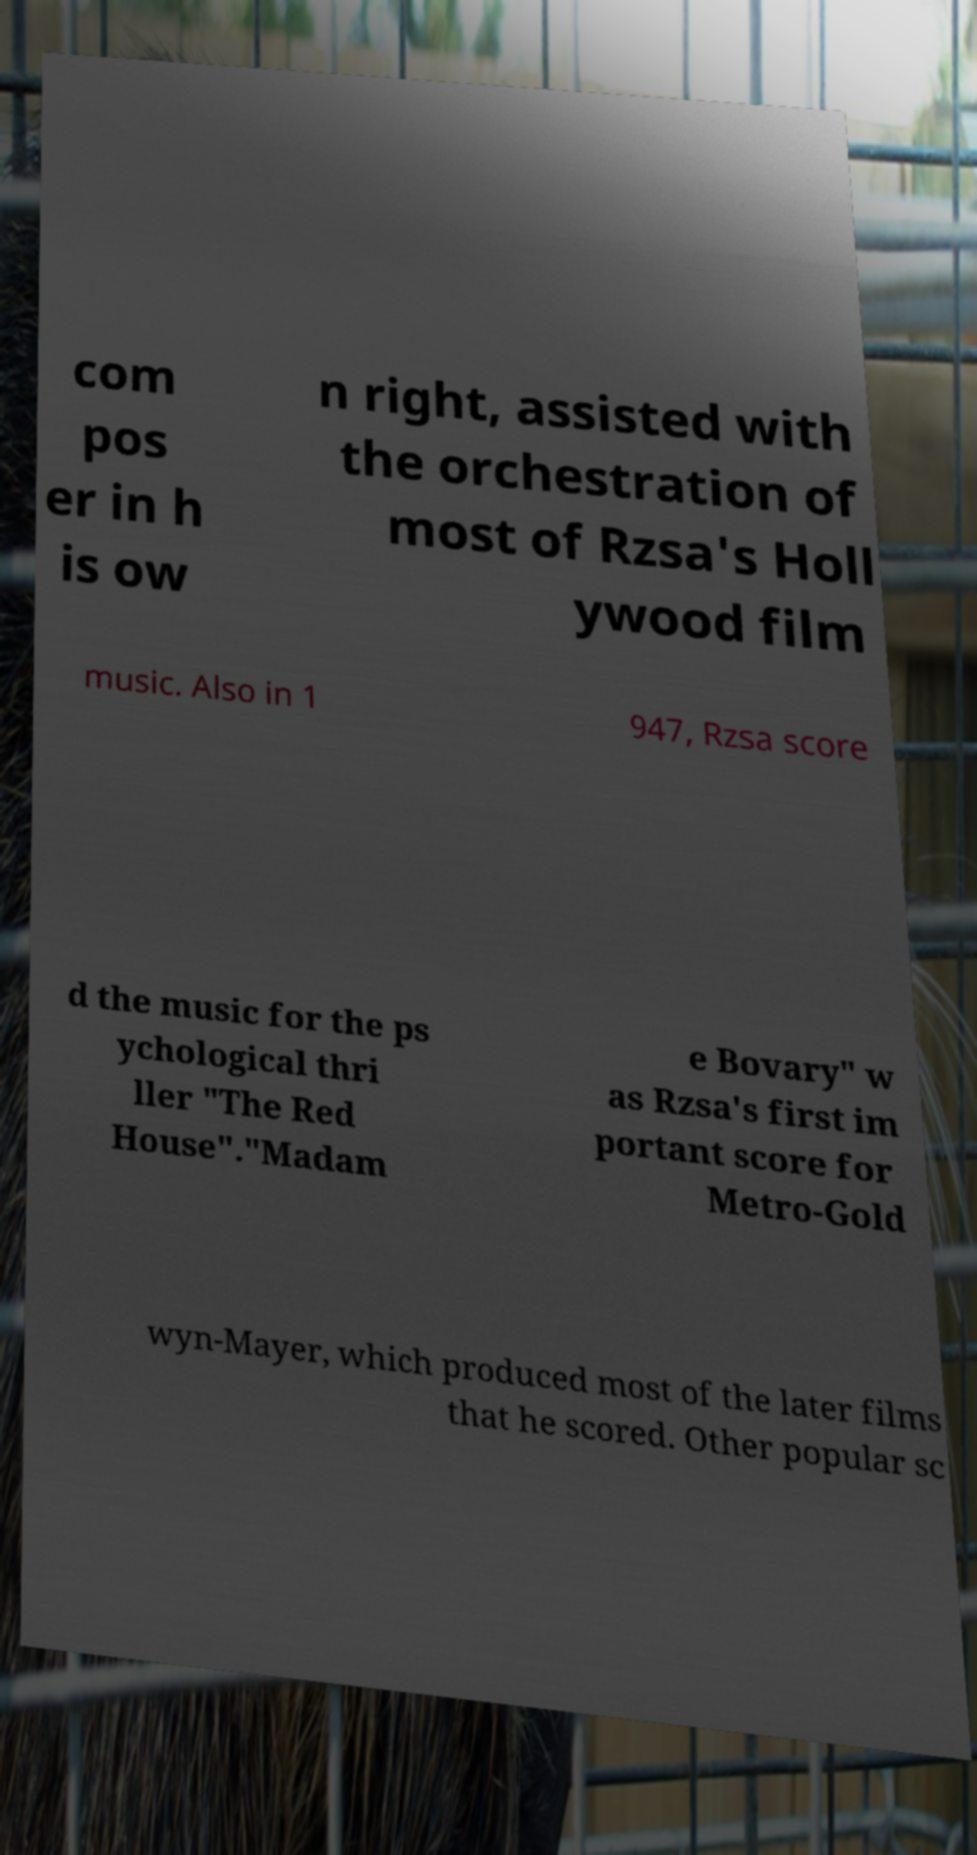Can you accurately transcribe the text from the provided image for me? com pos er in h is ow n right, assisted with the orchestration of most of Rzsa's Holl ywood film music. Also in 1 947, Rzsa score d the music for the ps ychological thri ller "The Red House"."Madam e Bovary" w as Rzsa's first im portant score for Metro-Gold wyn-Mayer, which produced most of the later films that he scored. Other popular sc 